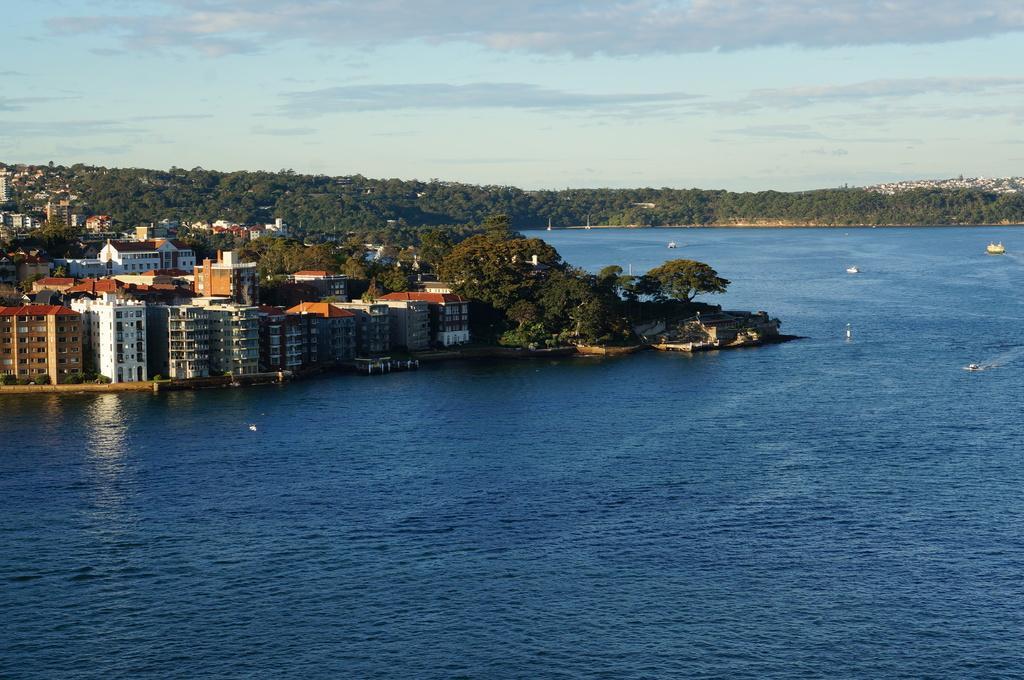Can you describe this image briefly? In this picture we can see boats above the water, trees and buildings. In the background of the image we can see the sky. 